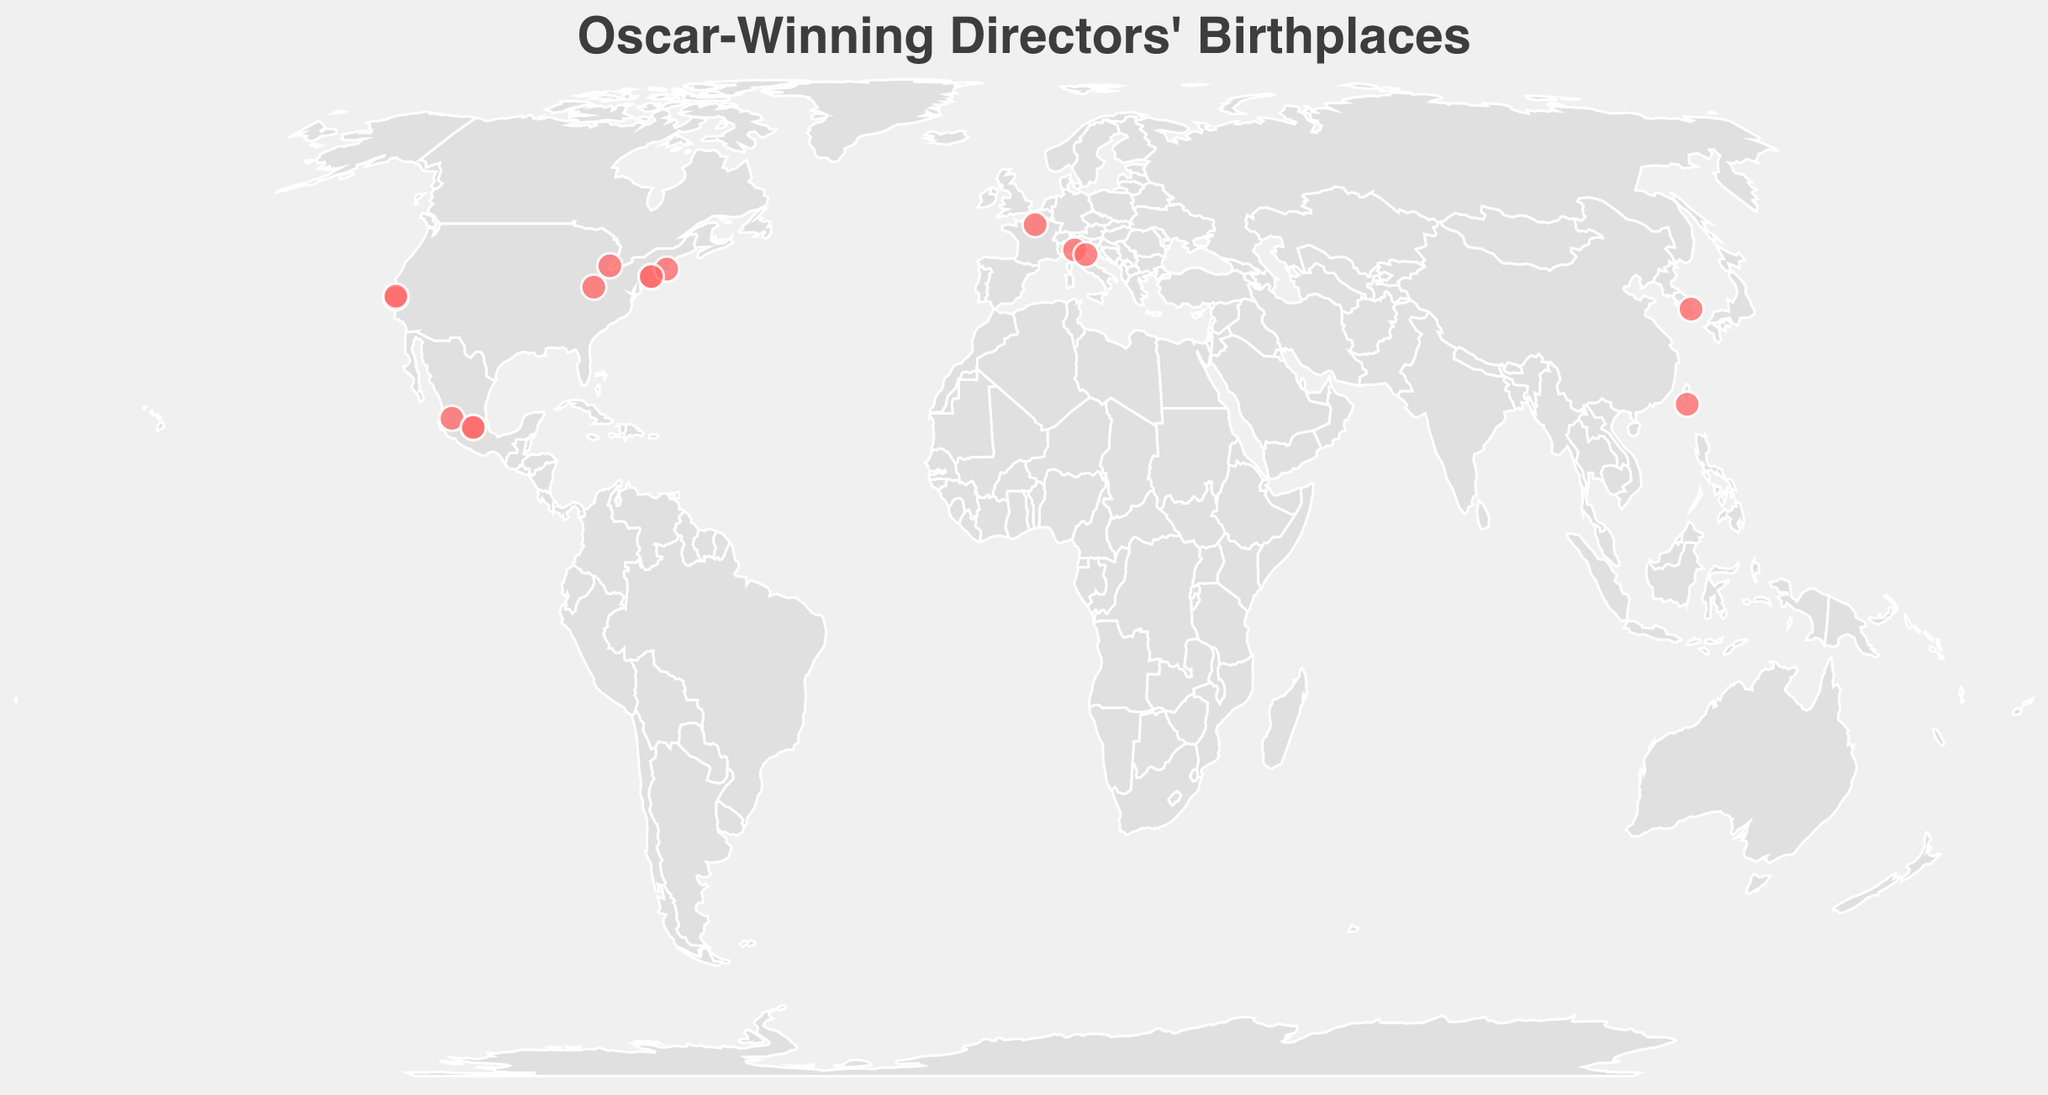Where was Steven Spielberg born? Look for the data point representing Steven Spielberg on the map. The tooltip indicates his birthplace as Cincinnati.
Answer: Cincinnati Which directors were born in Mexico City? Review the data points, particularly those showing "Mexico City" in the tooltip. Alfonso Cuarón and Alejandro González Iñárritu were born there.
Answer: Alfonso Cuarón, Alejandro González Iñárritu Who is the most recent Oscar-winning director and their birthplace? Identify the point with the highest year, which is 2020 for Bong Joon-ho. His birthplace, as shown in the tooltip, is Daegu.
Answer: Bong Joon-ho, Daegu How many directors were born in the United States? Identify the data points with birthplaces in the United States (Cincinnati, San Carlos, New York City, Providence, Detroit, Brooklyn, San Francisco). Count these points. Seven directors were born in the U.S.
Answer: 7 Calculate the average latitude and longitude of directors born in Italy. Two directors, Federico Fellini and Bernardo Bertolucci, were born in Italy with coordinates (44.0678, 12.5695) and (44.8015, 10.3279). The average latitude is (44.0678 + 44.8015) / 2 = 44.43465, and the average longitude is (12.5695 + 10.3279) / 2 = 11.4487.
Answer: Latitude: 44.43465, Longitude: 11.4487 Which birthplaces are located in Europe? Look for points with European coordinates. The birthplaces in Europe are Paris, Parma, and Rimini, representing Roman Polanski, Bernardo Bertolucci, and Federico Fellini.
Answer: Paris, Parma, Rimini Compare the latitudes of Steven Spielberg and Martin Scorsese. Who was born further north? Check the latitudes provided for Steven Spielberg (39.1031) and Martin Scorsese (40.7128). Higher latitude means further north, so Martin Scorsese was born further north.
Answer: Martin Scorsese Who are the directors born in Asia and their birthplaces? Look for directors with birthplaces in Asia (coordinates with countries in Asia). Bong Joon-ho and Ang Lee were born in Daegu and Chaochou, respectively.
Answer: Bong Joon-ho, Daegu; Ang Lee, Chaochou 